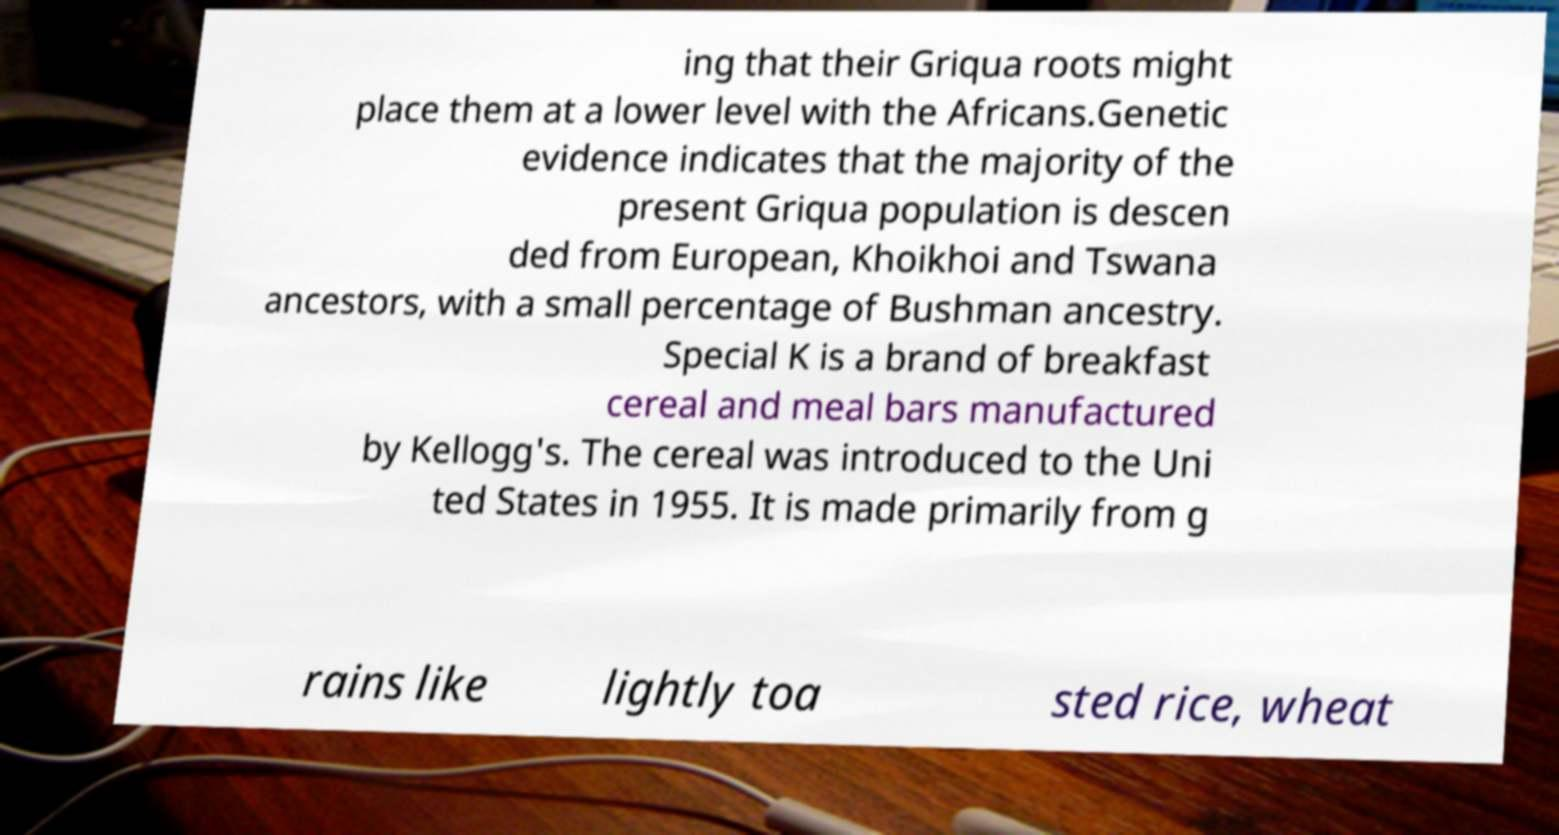Please identify and transcribe the text found in this image. ing that their Griqua roots might place them at a lower level with the Africans.Genetic evidence indicates that the majority of the present Griqua population is descen ded from European, Khoikhoi and Tswana ancestors, with a small percentage of Bushman ancestry. Special K is a brand of breakfast cereal and meal bars manufactured by Kellogg's. The cereal was introduced to the Uni ted States in 1955. It is made primarily from g rains like lightly toa sted rice, wheat 